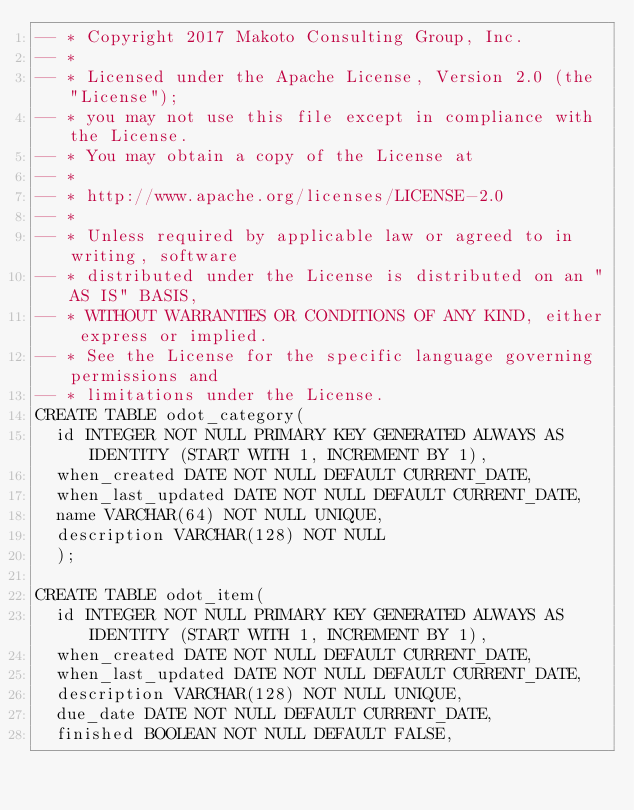Convert code to text. <code><loc_0><loc_0><loc_500><loc_500><_SQL_>-- * Copyright 2017 Makoto Consulting Group, Inc.
-- * 
-- * Licensed under the Apache License, Version 2.0 (the "License");
-- * you may not use this file except in compliance with the License.
-- * You may obtain a copy of the License at
-- * 
-- * http://www.apache.org/licenses/LICENSE-2.0
-- * 
-- * Unless required by applicable law or agreed to in writing, software
-- * distributed under the License is distributed on an "AS IS" BASIS,
-- * WITHOUT WARRANTIES OR CONDITIONS OF ANY KIND, either express or implied.
-- * See the License for the specific language governing permissions and
-- * limitations under the License.
CREATE TABLE odot_category(
  id INTEGER NOT NULL PRIMARY KEY GENERATED ALWAYS AS IDENTITY (START WITH 1, INCREMENT BY 1),
  when_created DATE NOT NULL DEFAULT CURRENT_DATE,
  when_last_updated DATE NOT NULL DEFAULT CURRENT_DATE,
  name VARCHAR(64) NOT NULL UNIQUE,
  description VARCHAR(128) NOT NULL
  );

CREATE TABLE odot_item(
  id INTEGER NOT NULL PRIMARY KEY GENERATED ALWAYS AS IDENTITY (START WITH 1, INCREMENT BY 1),
  when_created DATE NOT NULL DEFAULT CURRENT_DATE,
  when_last_updated DATE NOT NULL DEFAULT CURRENT_DATE,
  description VARCHAR(128) NOT NULL UNIQUE,
  due_date DATE NOT NULL DEFAULT CURRENT_DATE,
  finished BOOLEAN NOT NULL DEFAULT FALSE,</code> 